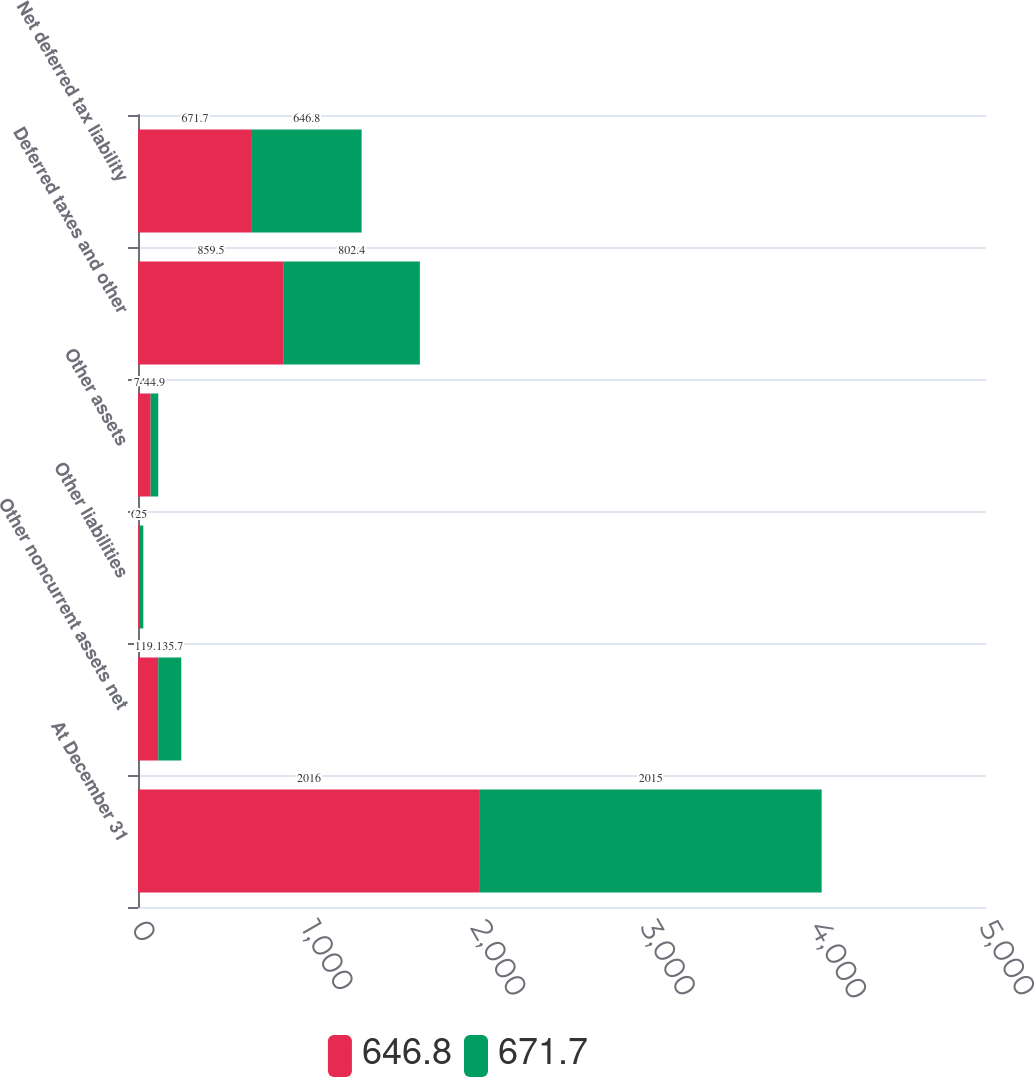<chart> <loc_0><loc_0><loc_500><loc_500><stacked_bar_chart><ecel><fcel>At December 31<fcel>Other noncurrent assets net<fcel>Other liabilities<fcel>Other assets<fcel>Deferred taxes and other<fcel>Net deferred tax liability<nl><fcel>646.8<fcel>2016<fcel>119.5<fcel>6.3<fcel>74.6<fcel>859.5<fcel>671.7<nl><fcel>671.7<fcel>2015<fcel>135.7<fcel>25<fcel>44.9<fcel>802.4<fcel>646.8<nl></chart> 